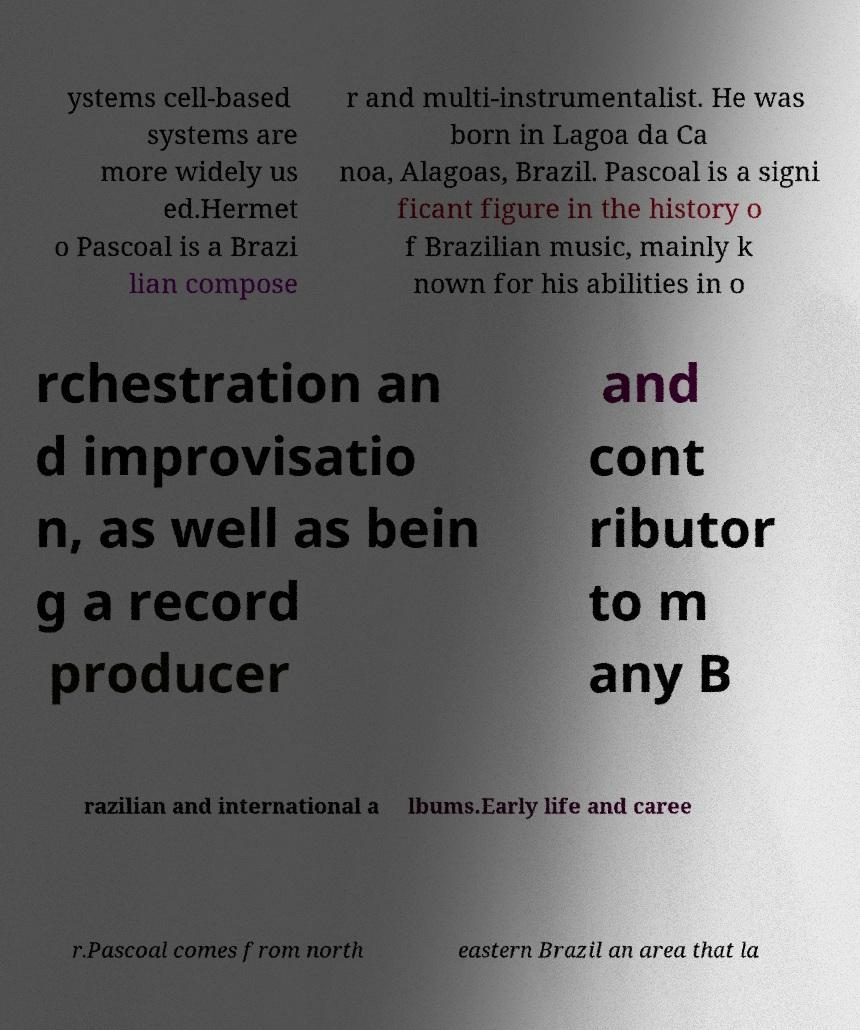What messages or text are displayed in this image? I need them in a readable, typed format. ystems cell-based systems are more widely us ed.Hermet o Pascoal is a Brazi lian compose r and multi-instrumentalist. He was born in Lagoa da Ca noa, Alagoas, Brazil. Pascoal is a signi ficant figure in the history o f Brazilian music, mainly k nown for his abilities in o rchestration an d improvisatio n, as well as bein g a record producer and cont ributor to m any B razilian and international a lbums.Early life and caree r.Pascoal comes from north eastern Brazil an area that la 